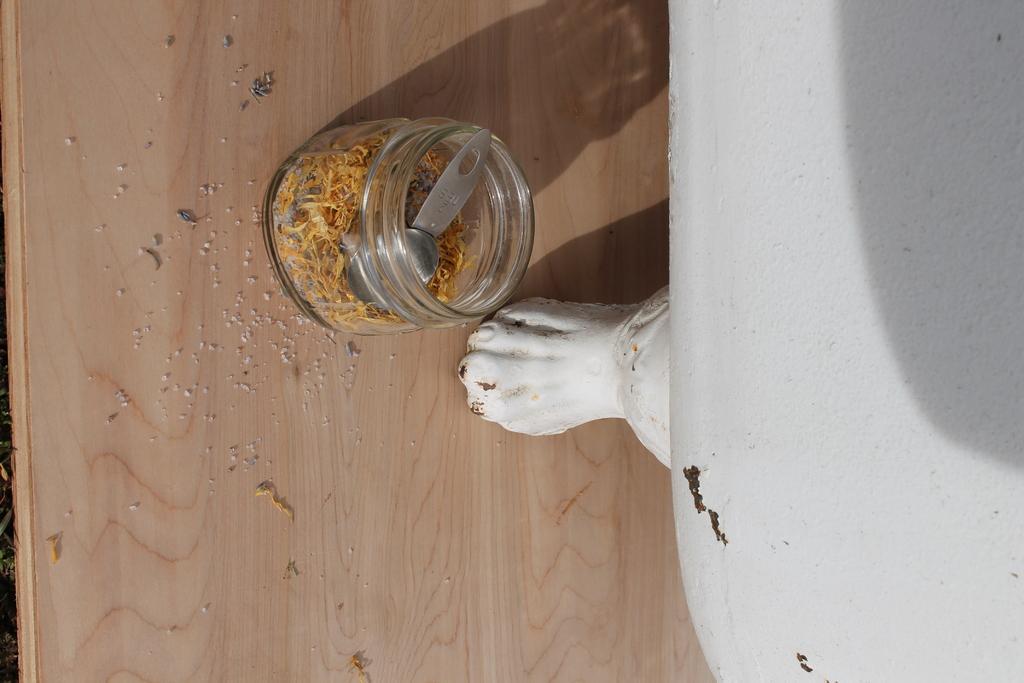Could you give a brief overview of what you see in this image? In this image, we can see a table. In the middle of the table, we can see a jar, in the jar, we can see some object and a spoon. On the right side, we can also see another table which is in white color. 